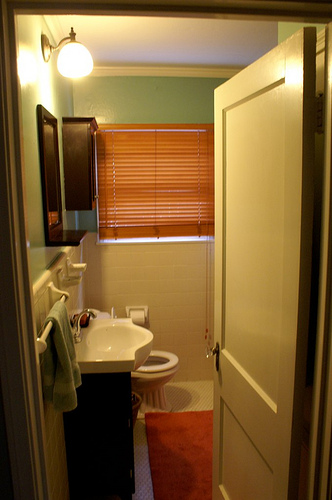What's the position of the toilet? The toilet is positioned towards the center-right part of the image, slightly tucked behind the open door and adjacent to the sink area. 